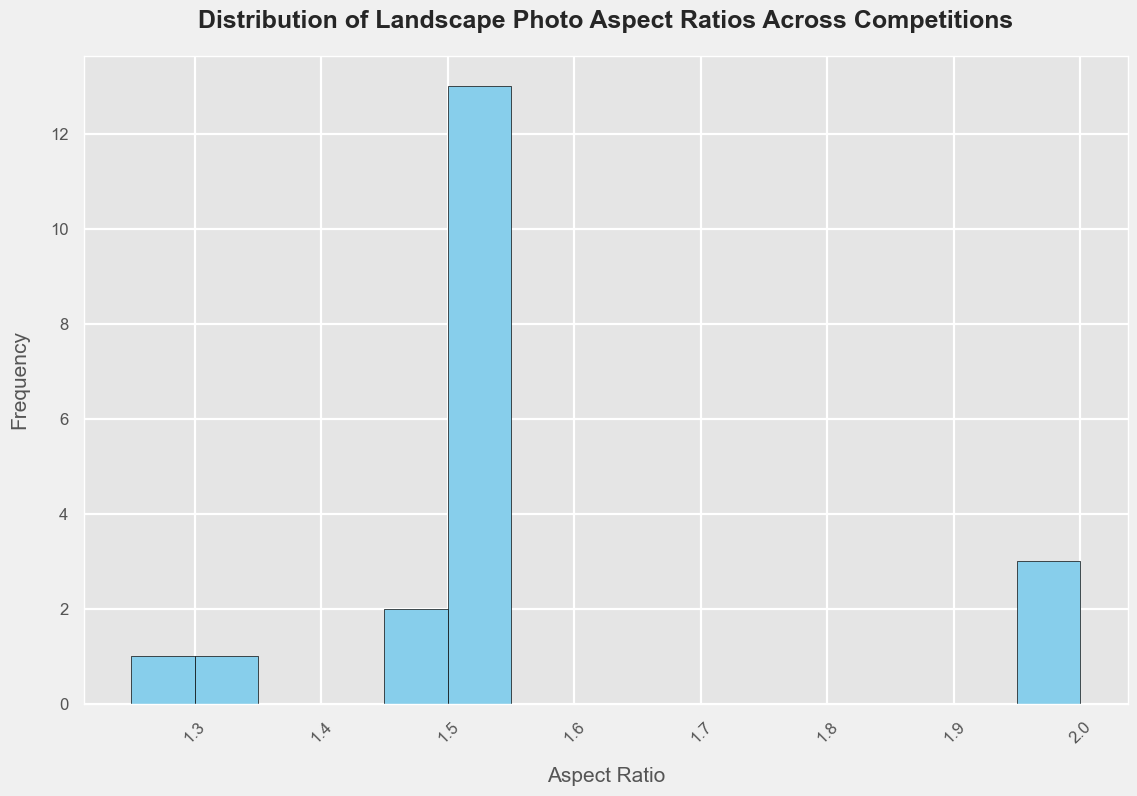What is the most common range of aspect ratios in landscape photography competitions? To determine the most common range of aspect ratios, observe the range on the x-axis where the histogram has the tallest bars, indicating the highest frequency. This means that the majority of the photos have aspect ratios within this range.
Answer: Around 1.5-2.0 How many different aspect ratio categories are represented in the histogram? Count the number of bins (bars) on the x-axis, each representing a range of aspect ratios.
Answer: 15 Which aspect ratio appears to be the least common among the landscape photography competitions? To find the least common aspect ratio, look for the shortest bar in the histogram, which indicates the lowest frequency.
Answer: Near 3.0 Is there a wider range of aspect ratios or a concentrated range within the landscape photography competitions according to the histogram? Analyze the spread of the bars along the x-axis. If the bars are spread out evenly, then there is a wide range; if they are concentrated in a small section, then the range is more concentrated.
Answer: Concentrated range What is the frequency of the most common aspect ratio in the histogram? Identify the tallest bar in the histogram and read the value on the y-axis that corresponds to the top of this bar.
Answer: Approximately 3 Comparing the aspect ratios of 1.33 and 2.33, which one shows a higher frequency in the histogram? Locate the bars corresponding to the aspect ratios 1.33 and 2.33 on the x-axis and compare their heights. The taller bar indicates a higher frequency.
Answer: 1.33 What can be inferred about the standard aspect ratios for landscape photography based on the histogram? By analyzing the concentration of bars around specific aspect ratios and their frequencies, one can infer commonly used aspect ratios in landscape photography competitions.
Answer: Around 1.5-2.0 are standard How does the diversity of aspect ratios in the histogram potentially impact the aesthetic evaluation of landscape photos? Consider the aesthetic implications of having a range of aspect ratios. A wider range suggests more diversity in framing and composition, which can affect how photos are aesthetically evaluated.
Answer: Greater diversity in framing and composition Which aspect ratio range contains the median value among the presented competitions? To find the median, observe the histogram and locate the range where the cumulative frequency reaches 50%. This is around the middle of the data set.
Answer: Around 1.7-1.8 